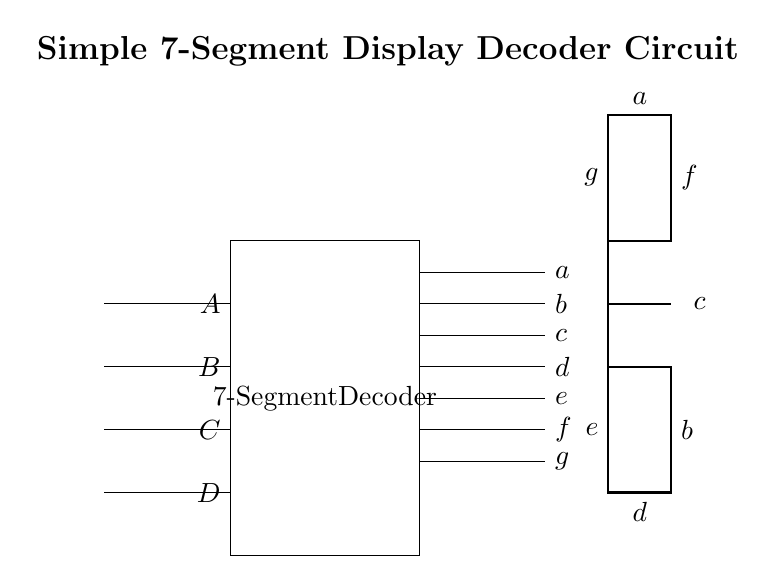What are the inputs to the decoder? The inputs to the decoder are signals labeled A, B, C, and D, which enter the left side of the decoder block.
Answer: A, B, C, D How many output segments does the decoder control? The decoder controls seven output segments, labeled a, b, c, d, e, f, and g, which represent the segments of the display.
Answer: Seven What is the function of the 7-segment decoder? The function of the 7-segment decoder is to convert binary inputs into signals that control the individual segments of a 7-segment display corresponding to numeric values.
Answer: To visualize numeric outputs Which segment corresponds to the output labeled 'g'? The output labeled 'g' corresponds to the upper horizontal segment on the 7-segment display, located at the center and above the middle horizontal segment labeled 'd'.
Answer: Upper horizontal segment What is the shape of the 7-segment display? The shape of the 7-segment display is a rectangular figure with the 7 segments arranged in a figure-eight manner to represent digits.
Answer: Rectangular Which outputs will be activated for the input combination 0110? For the binary input 0110, the activated outputs are a, b, c, d, and e, which represents the decimal digit 6 on the display.
Answer: a, b, c, d, e 